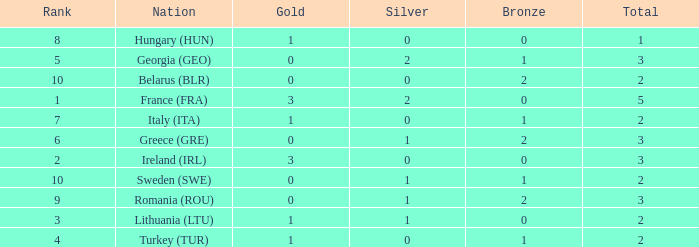What's the rank of Turkey (TUR) with a total more than 2? 0.0. 